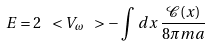<formula> <loc_0><loc_0><loc_500><loc_500>E = 2 \ < V _ { \omega } \ > - \int \, d x \, \frac { \mathcal { C } ( x ) } { 8 \pi m a }</formula> 